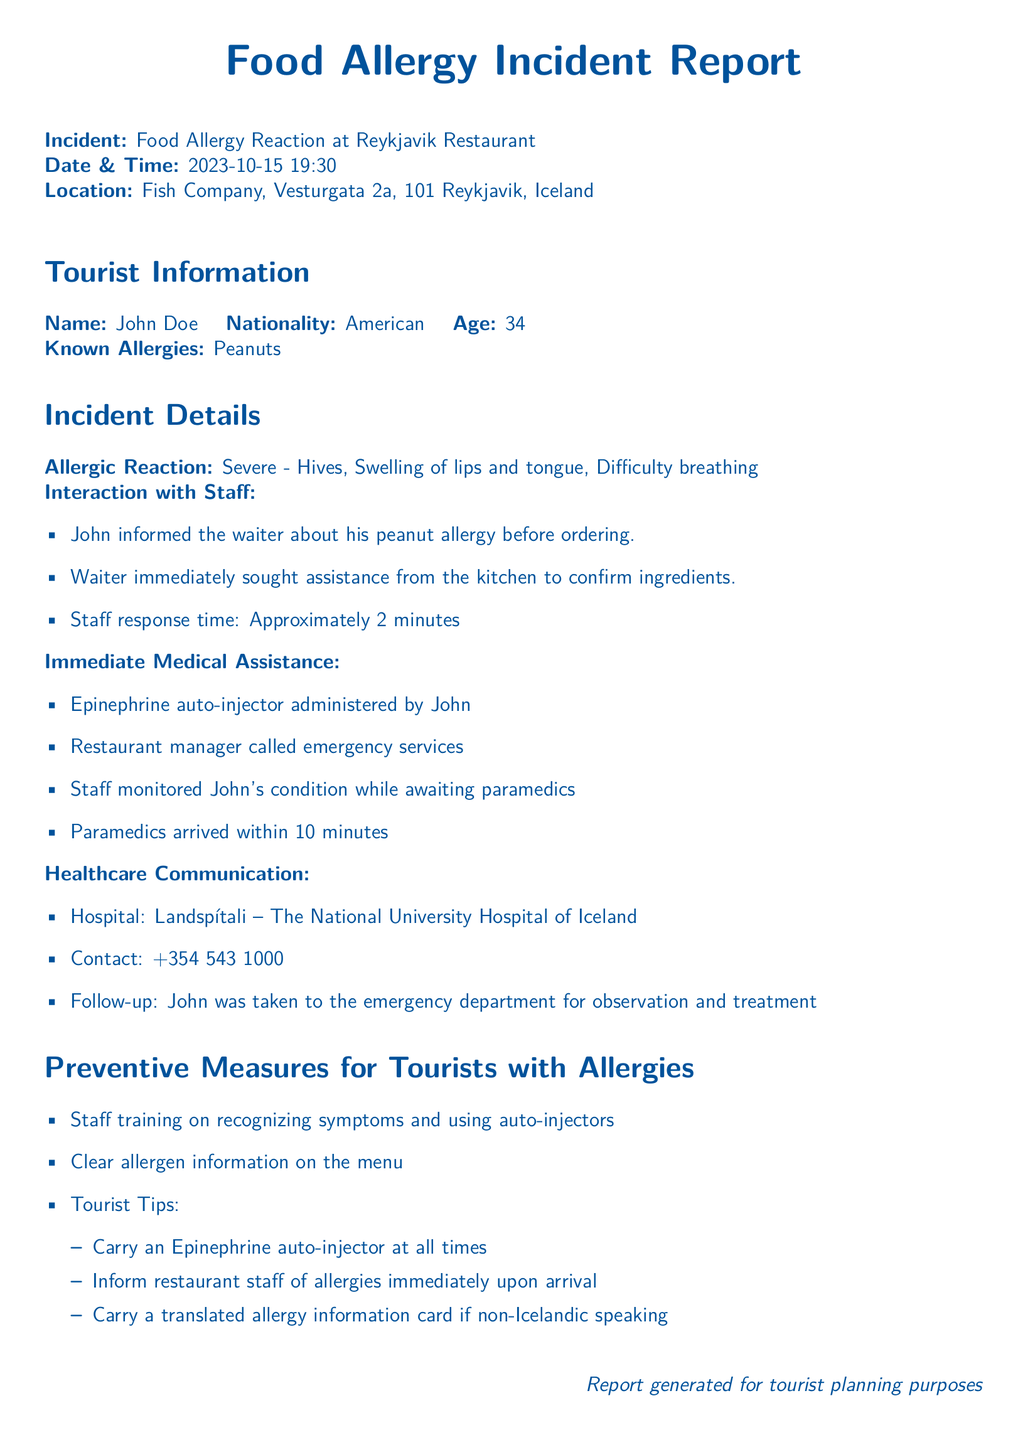What was the date of the incident? The date of the incident is specified in the document as 2023-10-15.
Answer: 2023-10-15 What is the location of the restaurant? The document provides the full address of the restaurant where the incident occurred, which is Fish Company, Vesturgata 2a, 101 Reykjavik, Iceland.
Answer: Fish Company, Vesturgata 2a, 101 Reykjavik, Iceland What was John Doe's known allergy? The document indicates the specific allergy that John Doe has, which is peanuts.
Answer: Peanuts How long did the staff take to respond? The document mentions the staff's response time as approximately 2 minutes.
Answer: Approximately 2 minutes What type of reaction did John experience? The document describes the allergic reaction as severe, with specific symptoms listed.
Answer: Severe What was the emergency contact number for the hospital? The document provides the contact number for the hospital where John was taken as +354 543 1000.
Answer: +354 543 1000 What preventive measure is suggested for tourists regarding allergy information? The document includes a tip for tourists, stating that they should carry an Epinephrine auto-injector at all times as a preventive measure.
Answer: Carry an Epinephrine auto-injector at all times How did the restaurant staff monitor John's condition? The document describes that while waiting for paramedics, the staff continuously monitored John's condition.
Answer: Monitored John's condition What was administered to John during the incident? The document states that an epinephrine auto-injector was administered by John himself during the allergic reaction.
Answer: Epinephrine auto-injector 